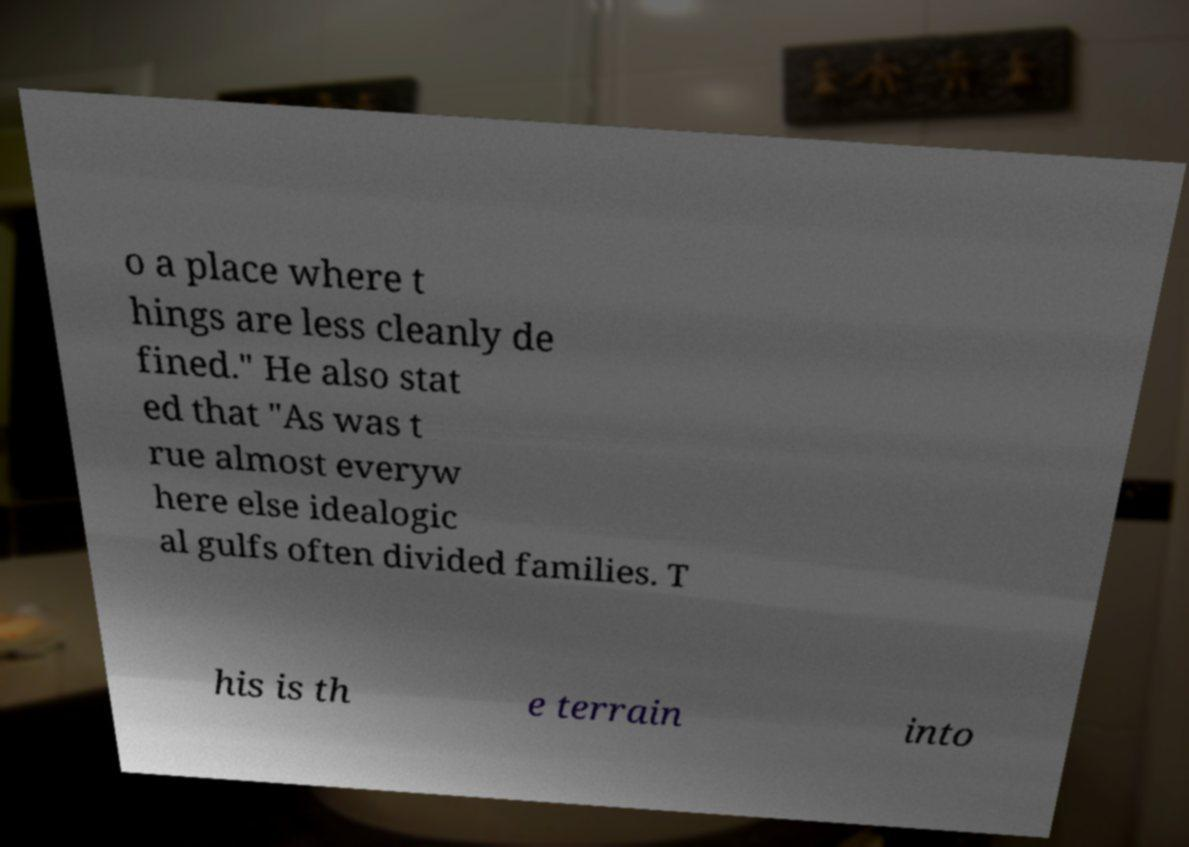What messages or text are displayed in this image? I need them in a readable, typed format. o a place where t hings are less cleanly de fined." He also stat ed that "As was t rue almost everyw here else idealogic al gulfs often divided families. T his is th e terrain into 